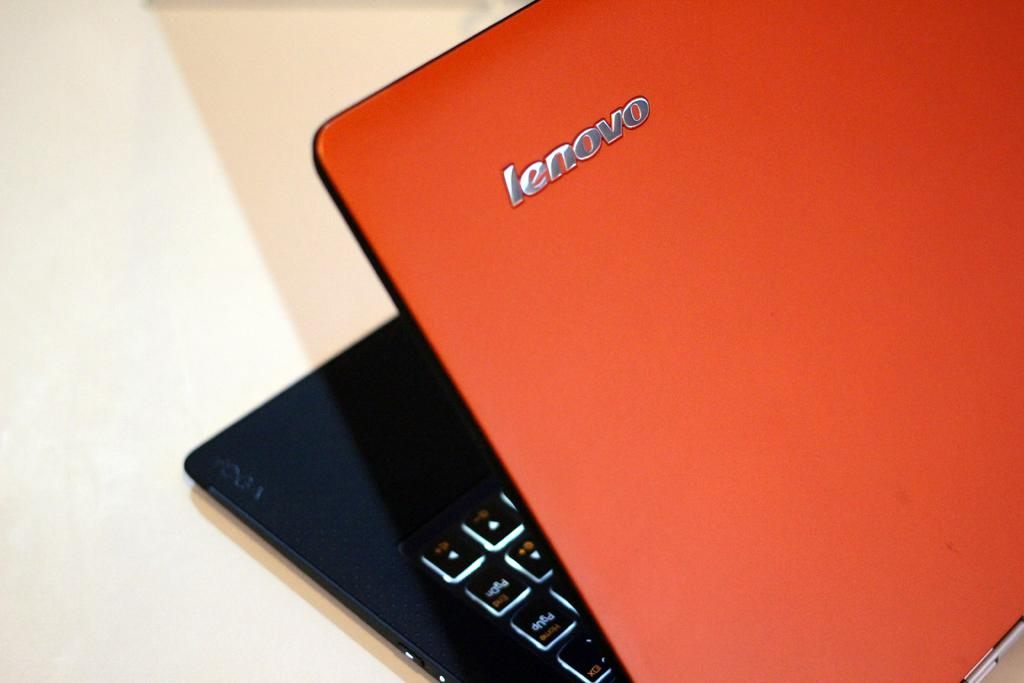Provide a one-sentence caption for the provided image. An orange and black Lenovo laptop is open at roughly a 35 degree angle. 